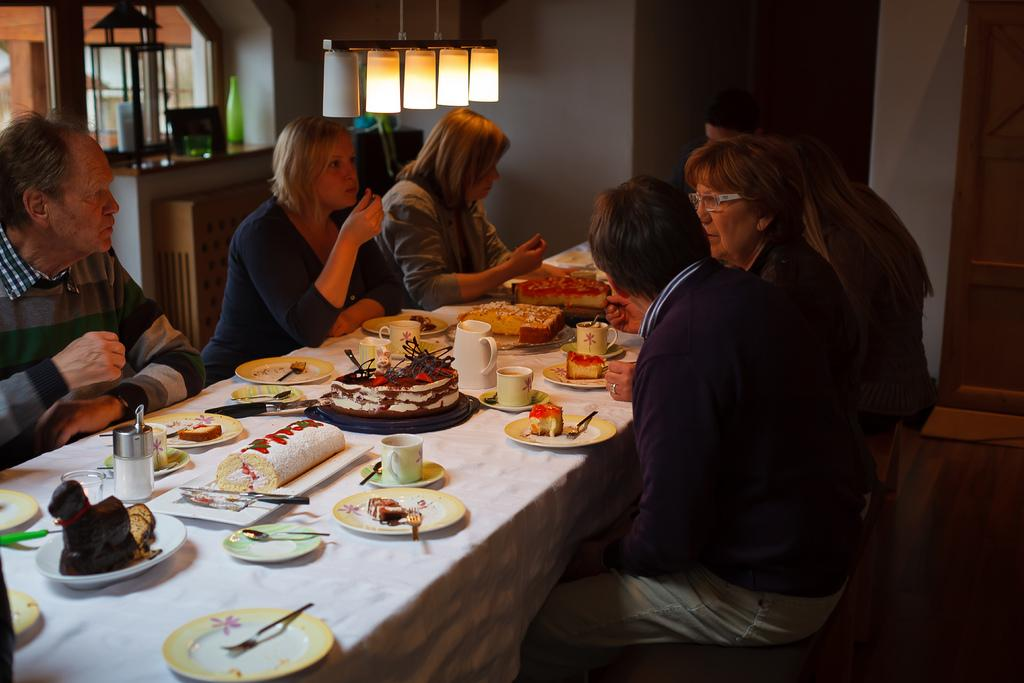Where is the image taken? The image is taken in a room. What can be seen on the ceiling of the room? There are lights on the top of the room. What furniture is present in the room? There is a table and chairs in the room. What items are on the table? There are plates, a bowl, knives, forks, spoons, a cup, a saucer, and a jar. What type of items are on the table? There are edibles on the table. How many dimes are on the table in the image? There are no dimes present on the table in the image. What type of plastic items can be seen on the table? There is no plastic present on the table in the image. 